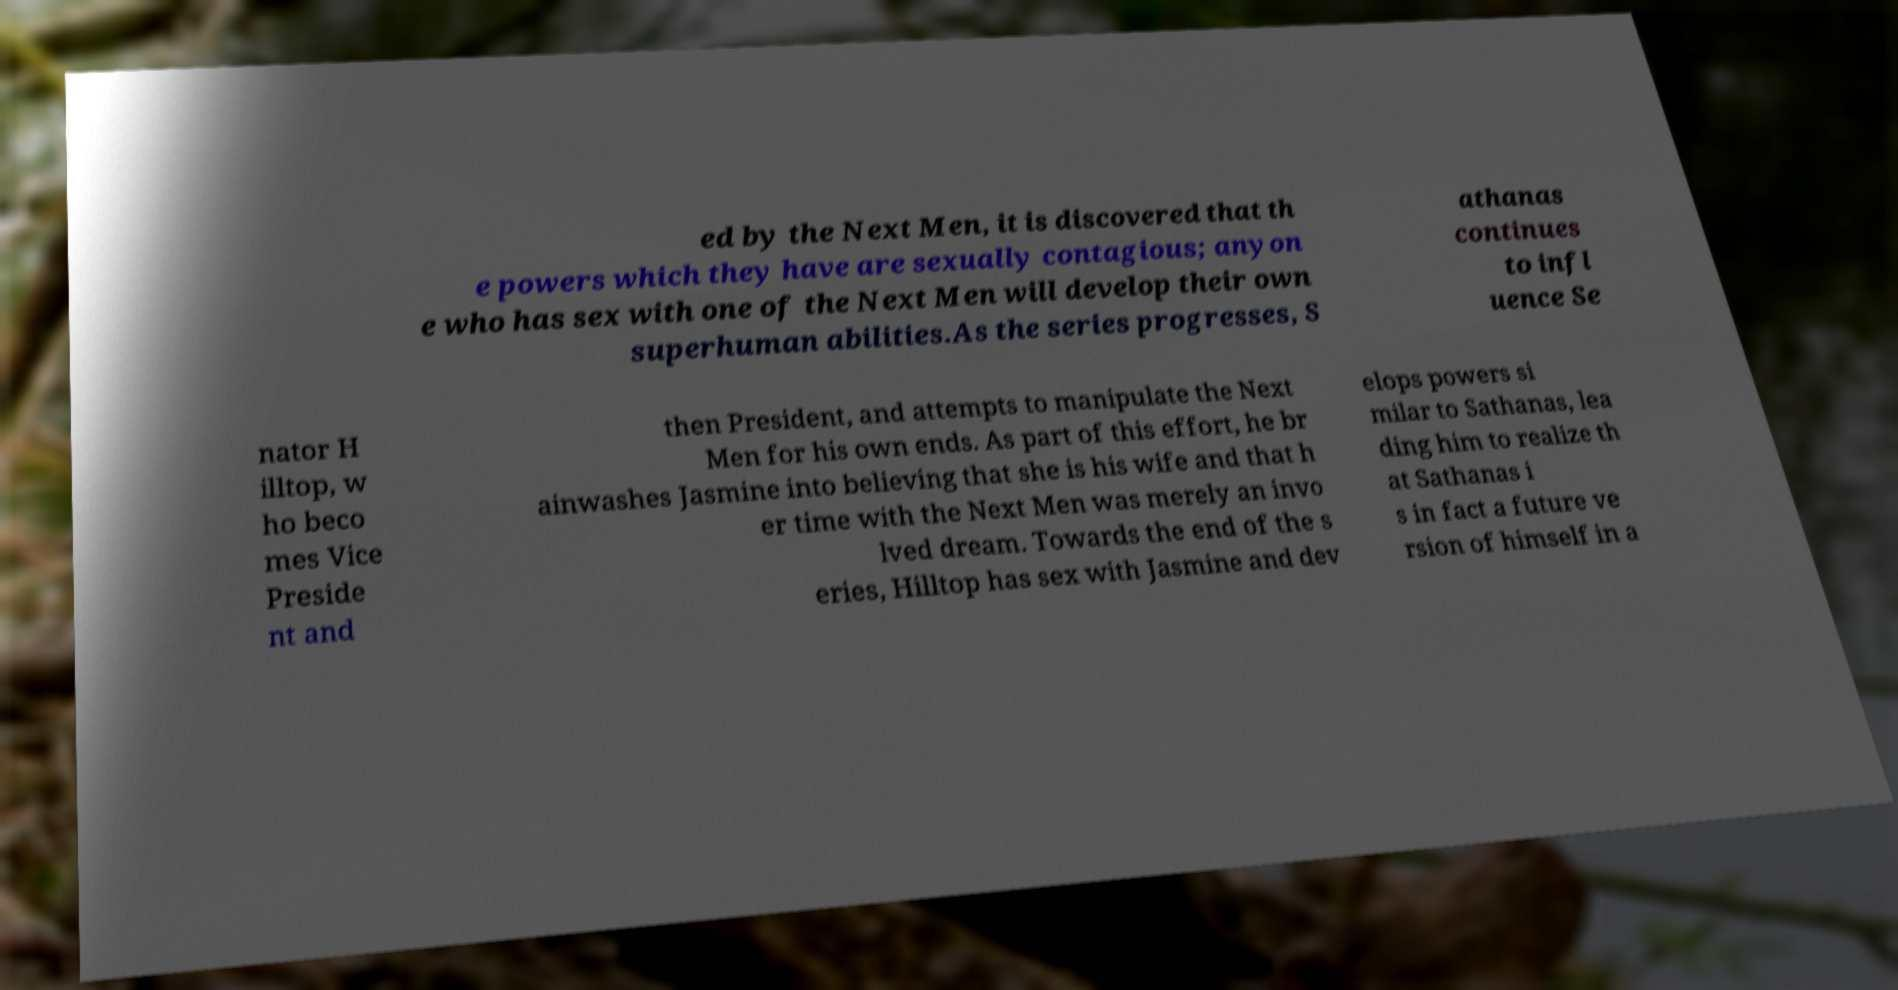For documentation purposes, I need the text within this image transcribed. Could you provide that? ed by the Next Men, it is discovered that th e powers which they have are sexually contagious; anyon e who has sex with one of the Next Men will develop their own superhuman abilities.As the series progresses, S athanas continues to infl uence Se nator H illtop, w ho beco mes Vice Preside nt and then President, and attempts to manipulate the Next Men for his own ends. As part of this effort, he br ainwashes Jasmine into believing that she is his wife and that h er time with the Next Men was merely an invo lved dream. Towards the end of the s eries, Hilltop has sex with Jasmine and dev elops powers si milar to Sathanas, lea ding him to realize th at Sathanas i s in fact a future ve rsion of himself in a 